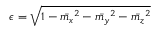Convert formula to latex. <formula><loc_0><loc_0><loc_500><loc_500>\epsilon = \sqrt { 1 - \bar { m _ { x } } ^ { 2 } - \bar { m _ { y } } ^ { 2 } - \bar { m _ { z } } ^ { 2 } }</formula> 